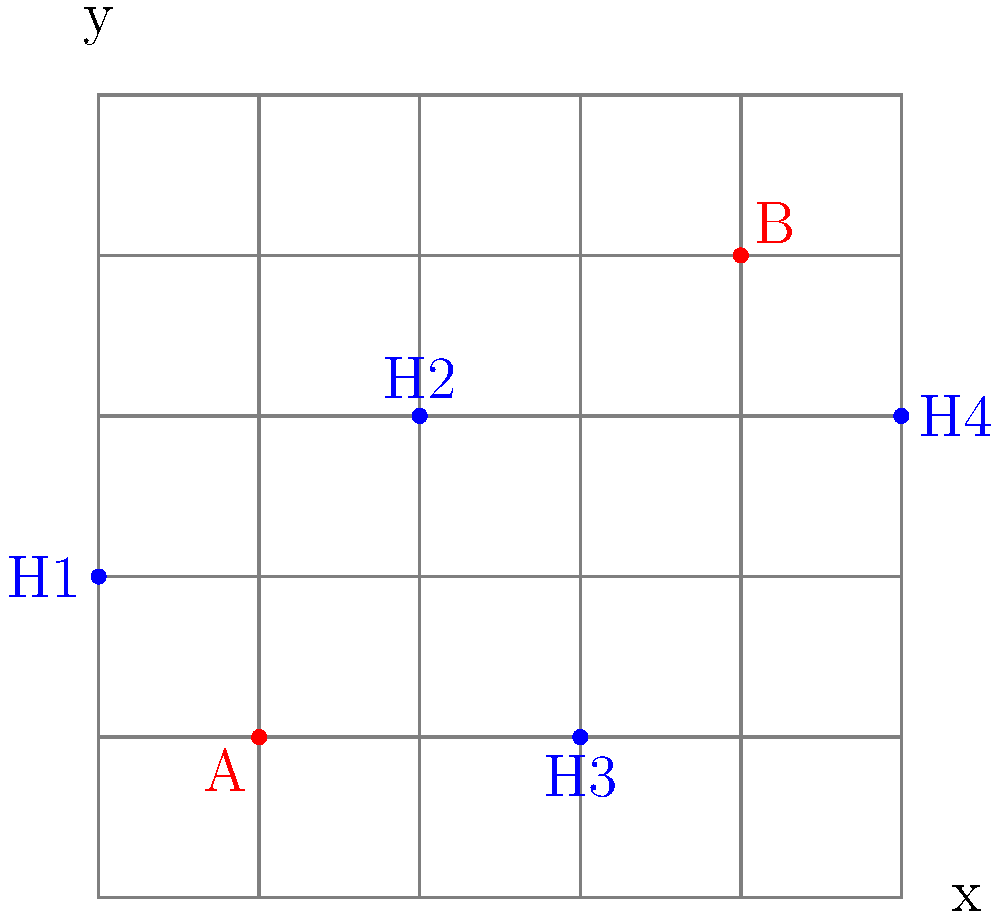As a retired firefighter, you're advising the city on optimal fire hydrant placement. The neighborhood is represented on a 5x5 grid, where each unit represents 100 feet. Existing fire hydrants are at points A(1,1) and B(4,4), shown in red. Houses are represented by blue dots H1(0,2), H2(2,3), H3(3,1), and H4(5,3). What are the coordinates of the optimal location for a new fire hydrant to minimize the maximum distance to any house? Let's approach this step-by-step:

1) First, we need to consider that the optimal location should minimize the maximum distance to any house. This suggests it should be centrally located.

2) Looking at the grid, we can see that the houses form a rough rectangle with corners at (0,1), (0,3), (5,1), and (5,3).

3) The center of this rectangle would be at (2.5, 2), which is not on a grid point. The closest grid points are (2,2) and (3,2).

4) Let's calculate the maximum distance from each of these points to the houses:

   From (2,2):
   - To H1: $\sqrt{2^2 + 0^2} = 2$ units
   - To H2: $\sqrt{0^2 + 1^2} = 1$ unit
   - To H3: $\sqrt{1^2 + 1^2} = \sqrt{2}$ units
   - To H4: $\sqrt{3^2 + 1^2} = \sqrt{10}$ units

   From (3,2):
   - To H1: $\sqrt{3^2 + 0^2} = 3$ units
   - To H2: $\sqrt{1^2 + 1^2} = \sqrt{2}$ units
   - To H3: $\sqrt{0^2 + 1^2} = 1$ unit
   - To H4: $\sqrt{2^2 + 1^2} = \sqrt{5}$ units

5) The maximum distance from (2,2) is $\sqrt{10}$ units, while from (3,2) it's 3 units.

6) Since $\sqrt{10} \approx 3.16 > 3$, the point (3,2) minimizes the maximum distance to any house.

Therefore, the optimal location for the new fire hydrant is at coordinates (3,2).
Answer: (3,2) 